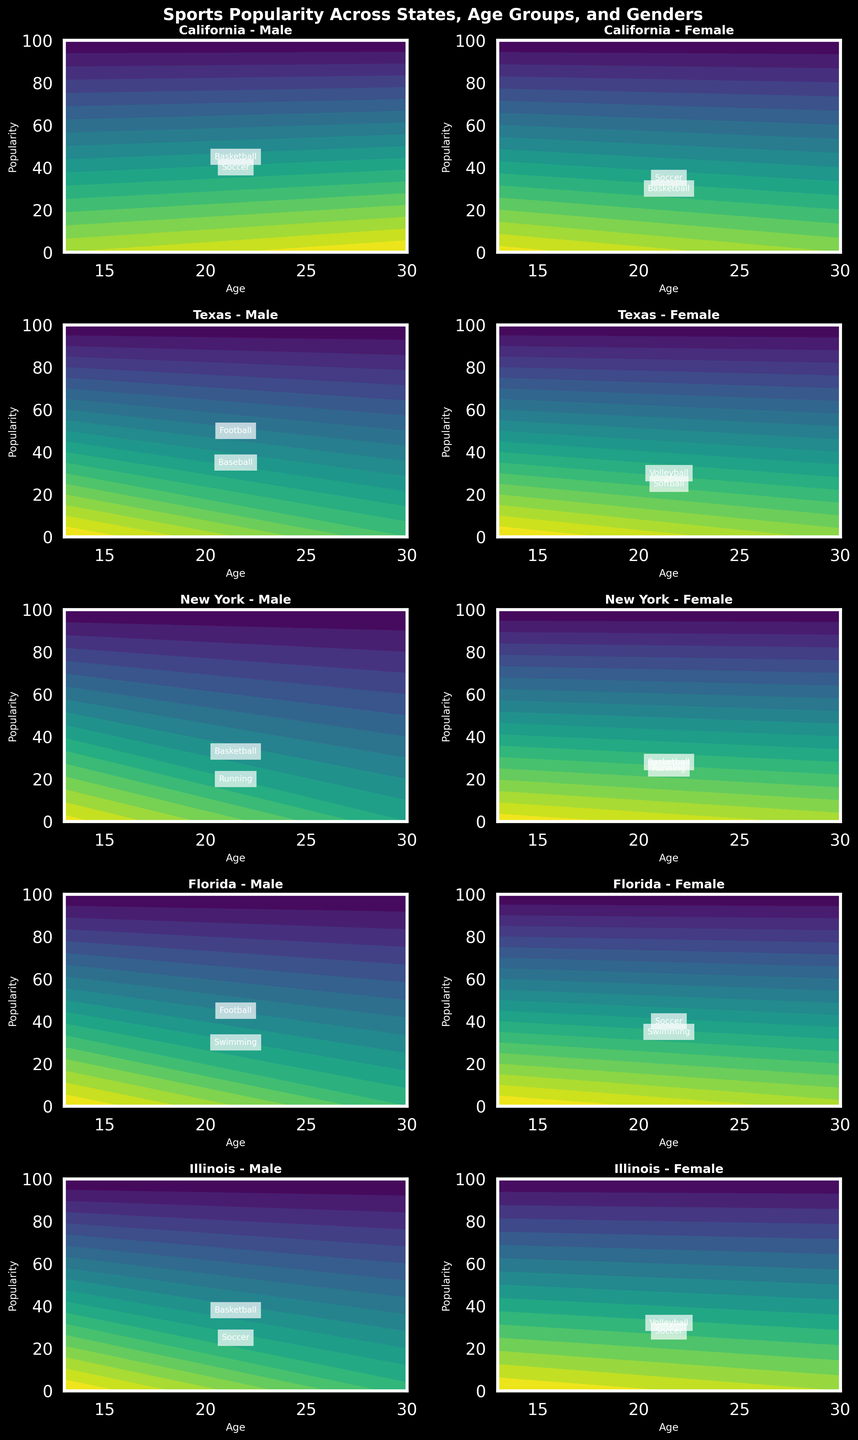What is the title of the figure? The title is located at the top of the figure and summarizes the main purpose of the visual. It reads "Sports Popularity Across States, Age Groups, and Genders".
Answer: Sports Popularity Across States, Age Groups, and Genders Which sport is popular among 13-18 year-old males in Texas? The subplot for Texas, male gender indicates the popularity of each sport by showing text annotations at the corresponding popularity level. Football is the sport annotated at the popularity level for 13-18 year-old males in Texas.
Answer: Football How does the popularity of basketball compare between 13-18 year-old males in California and Illinois? The subplot for California, male gender shows a popularity level of 33 for 13-18 year olds, while the Illinois, male gender shows a popularity level of 38 for the same age group.
Answer: Basketball is more popular in Illinois In which state is soccer most popular among 13-18 year-old females? Reviewing the subplots for each state focusing on the female gender in the 13-18 age group, California shows soccer with a popularity level of 35 which is the highest for this sport and demographic.
Answer: California Are there any states where swimming is the most popular sport for 19-30 year-old males? By checking the subplots for the male gender in each state, the Florida subplot shows swimming with the highest popularity level of 30 for 19-30 year olds.
Answer: Florida What is the difference in popularity of basketball between females aged 19-30 in California and New York? The subplot for California, female gender indicates a popularity level of 30 for basketball, while the subplot for New York, female gender indicates a popularity level of 28. The difference is 30 minus 28.
Answer: 2 Which sport has the highest popularity among 19-30 year-old females in Illinois? The subplot corresponding to Illinois, female gender indicates that soccer has the highest popularity with a value of 28.
Answer: Soccer What sport is the most popular among 13-18 year-old males in Florida? The subplot for Florida, male gender indicates the popularity level of 45 for football for the 13-18 age group.
Answer: Football 